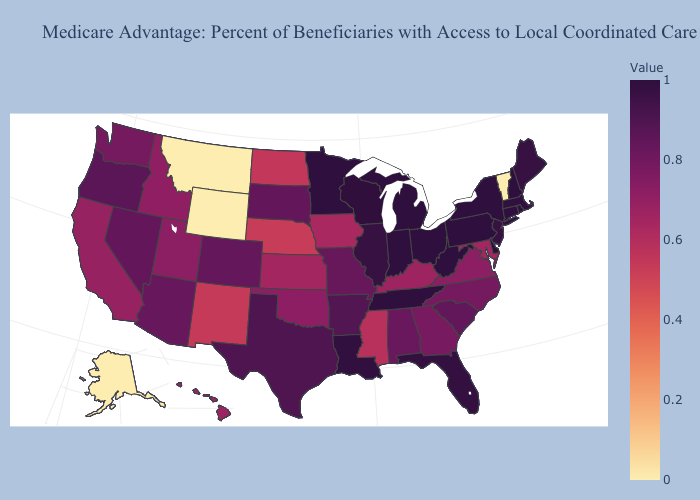Does Tennessee have the highest value in the South?
Keep it brief. No. Which states have the lowest value in the West?
Short answer required. Alaska, Montana, Wyoming. Among the states that border South Dakota , does Minnesota have the highest value?
Give a very brief answer. Yes. Among the states that border Vermont , does New York have the highest value?
Write a very short answer. Yes. Is the legend a continuous bar?
Be succinct. Yes. Does Mississippi have the lowest value in the South?
Keep it brief. Yes. Does Idaho have the highest value in the USA?
Be succinct. No. Which states have the lowest value in the MidWest?
Answer briefly. Nebraska. Does Alaska have the lowest value in the USA?
Give a very brief answer. Yes. Among the states that border Wyoming , which have the highest value?
Be succinct. South Dakota. 